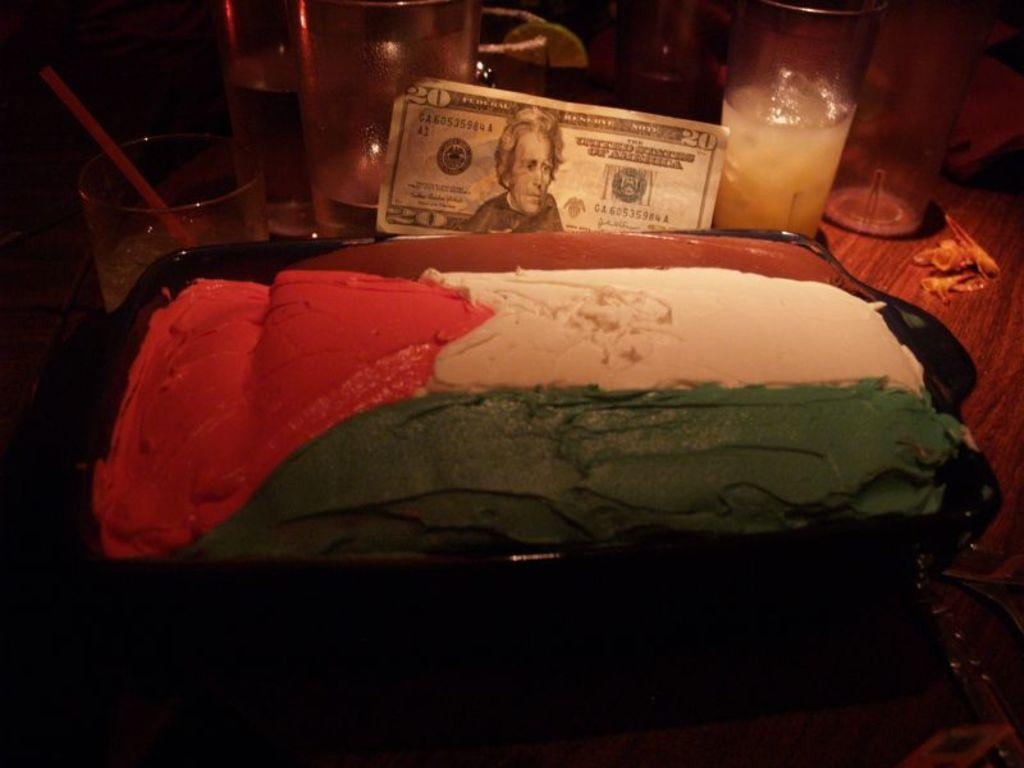What is in the tray that is visible in the image? There is a food item in the tray. What can be used for drinking in the image? There are glasses visible in the image. What piece of furniture is present in the image? There is a table in the image. What book is being read by the egg in the image? There is no egg or book present in the image. 